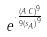<formula> <loc_0><loc_0><loc_500><loc_500>e ^ { \cdot \frac { ( A \cdot C ) ^ { 9 } } { 9 { ( s _ { A } ) } ^ { 9 } } }</formula> 